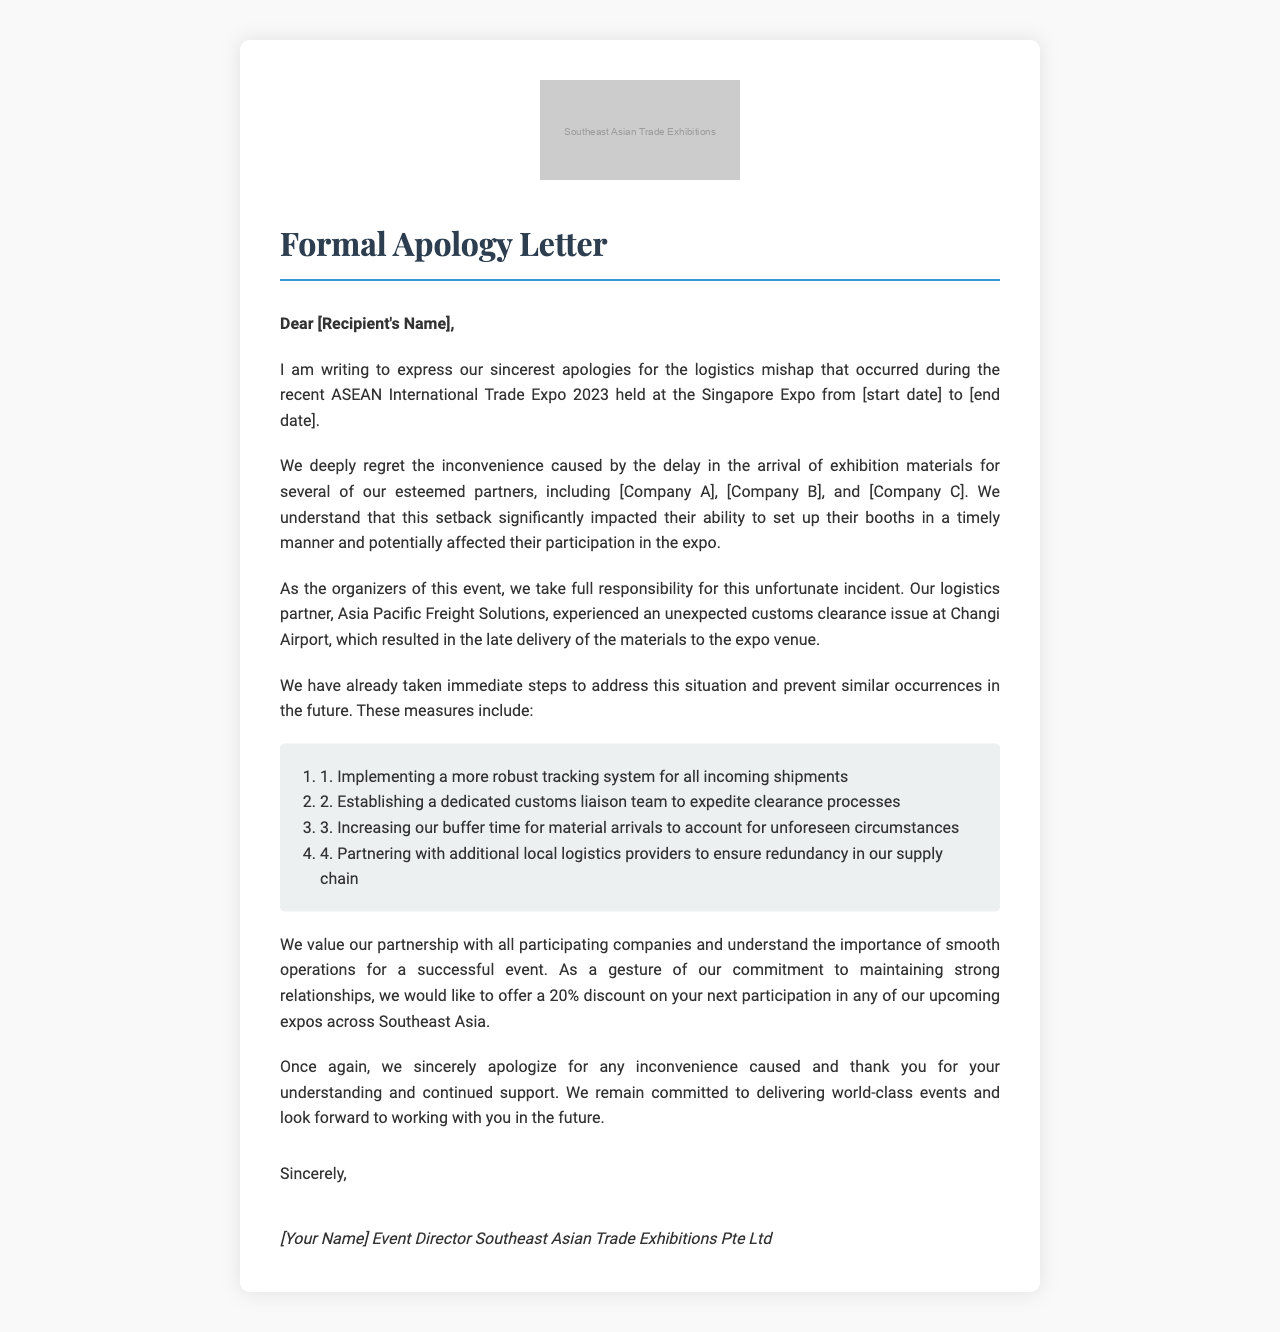What is the name of the event? The event is specifically named in the opening paragraph of the letter, referring to it as the ASEAN International Trade Expo 2023.
Answer: ASEAN International Trade Expo 2023 Where was the expo held? The venue is mentioned as the Singapore Expo in the opening paragraph of the letter.
Answer: Singapore Expo Who is the logistics partner mentioned? The logistics partner that is cited in the body paragraphs is Asia Pacific Freight Solutions.
Answer: Asia Pacific Freight Solutions What discount is offered for future participation? The closing paragraph states that a 20% discount is being offered as a gesture of commitment to the affected partners.
Answer: 20% Which companies were impacted by the logistics mishap? The body paragraphs list several companies affected, including Thai Silk Emporium Co., Ltd., Vinamilk Corporation, and Jollibee Foods Corporation.
Answer: Thai Silk Emporium Co., Ltd., Vinamilk Corporation, Jollibee Foods Corporation What immediate steps were taken to address the situation? The body paragraphs outline measures taken, detailing four specific actions for improvement, such as establishing a dedicated customs liaison team.
Answer: Implementing a more robust tracking system, establishing a dedicated customs liaison team, increasing buffer time for material arrivals, partnering with additional logistics providers What is the title of the person signing the letter? The closing section includes the signatory's title, which is Event Director of Southeast Asian Trade Exhibitions Pte Ltd.
Answer: Event Director How is the tone of the letter described in terms of cultural sensitivity? The letter's tone is described as respectful and reflects the importance of 'saving face' in Asian business culture according to additional considerations.
Answer: Respectful 